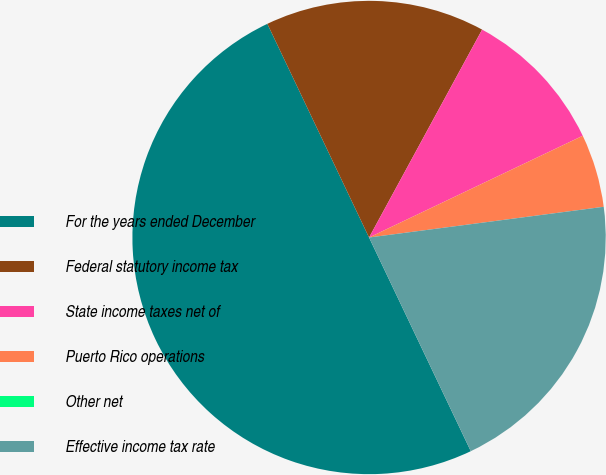<chart> <loc_0><loc_0><loc_500><loc_500><pie_chart><fcel>For the years ended December<fcel>Federal statutory income tax<fcel>State income taxes net of<fcel>Puerto Rico operations<fcel>Other net<fcel>Effective income tax rate<nl><fcel>50.0%<fcel>15.0%<fcel>10.0%<fcel>5.0%<fcel>0.0%<fcel>20.0%<nl></chart> 